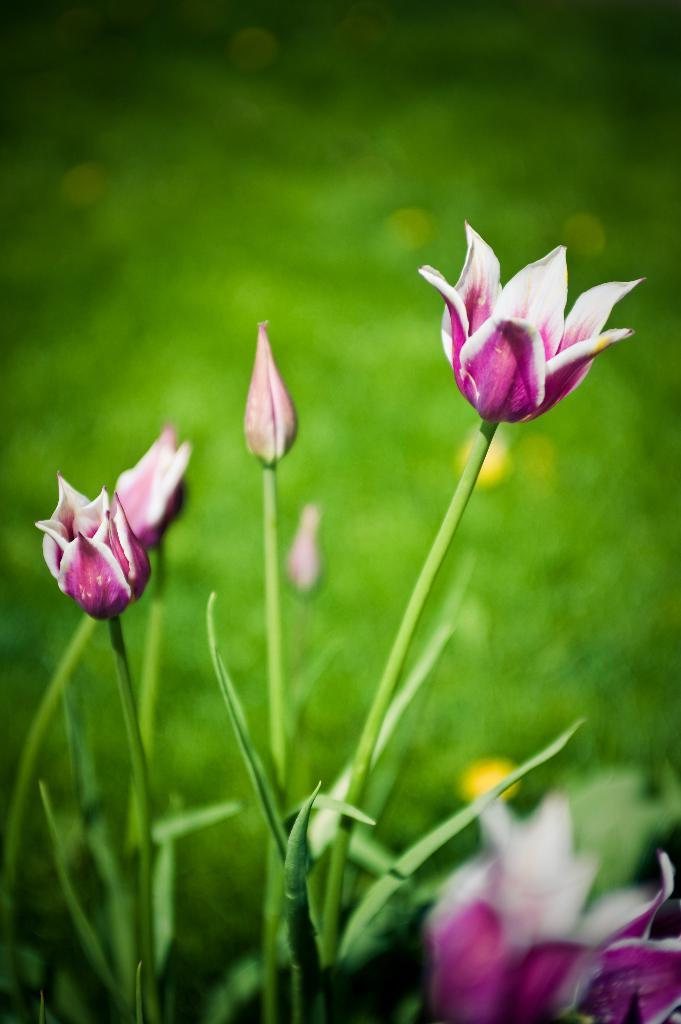What type of living organisms can be seen in the image? Plants and flowers are visible in the image. Can you describe the flowers in the image? The flowers in the image are part of the plants. What type of dress is the aunt wearing in the image? There is no aunt or dress present in the image; it only features plants and flowers. 